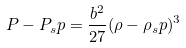Convert formula to latex. <formula><loc_0><loc_0><loc_500><loc_500>P - P _ { s } p = \frac { b ^ { 2 } } { 2 7 } ( \rho - \rho _ { s } p ) ^ { 3 }</formula> 